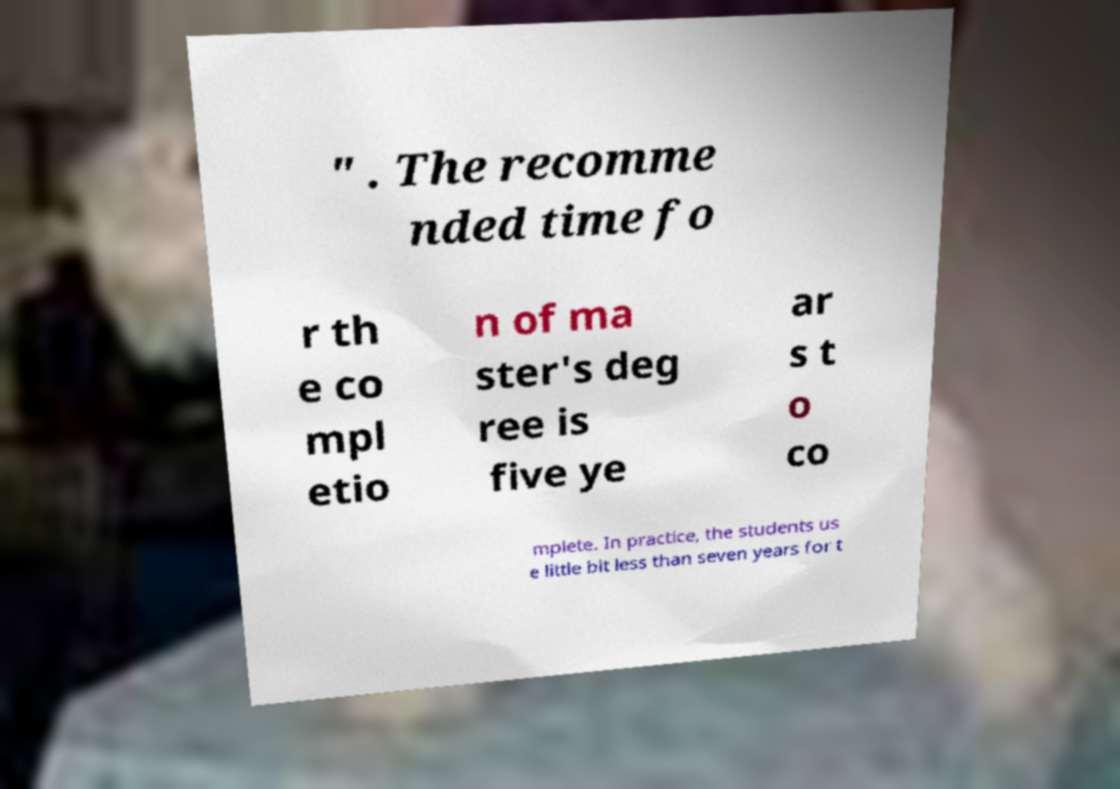Please identify and transcribe the text found in this image. " . The recomme nded time fo r th e co mpl etio n of ma ster's deg ree is five ye ar s t o co mplete. In practice, the students us e little bit less than seven years for t 